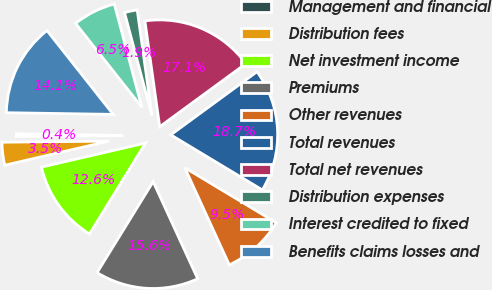Convert chart. <chart><loc_0><loc_0><loc_500><loc_500><pie_chart><fcel>Management and financial<fcel>Distribution fees<fcel>Net investment income<fcel>Premiums<fcel>Other revenues<fcel>Total revenues<fcel>Total net revenues<fcel>Distribution expenses<fcel>Interest credited to fixed<fcel>Benefits claims losses and<nl><fcel>0.41%<fcel>3.46%<fcel>12.59%<fcel>15.63%<fcel>9.54%<fcel>18.68%<fcel>17.15%<fcel>1.93%<fcel>6.5%<fcel>14.11%<nl></chart> 